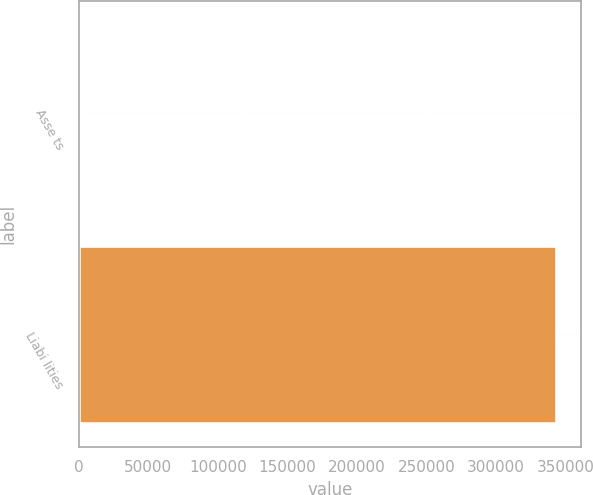Convert chart. <chart><loc_0><loc_0><loc_500><loc_500><bar_chart><fcel>Asse ts<fcel>Liabi lities<nl><fcel>2076<fcel>344068<nl></chart> 